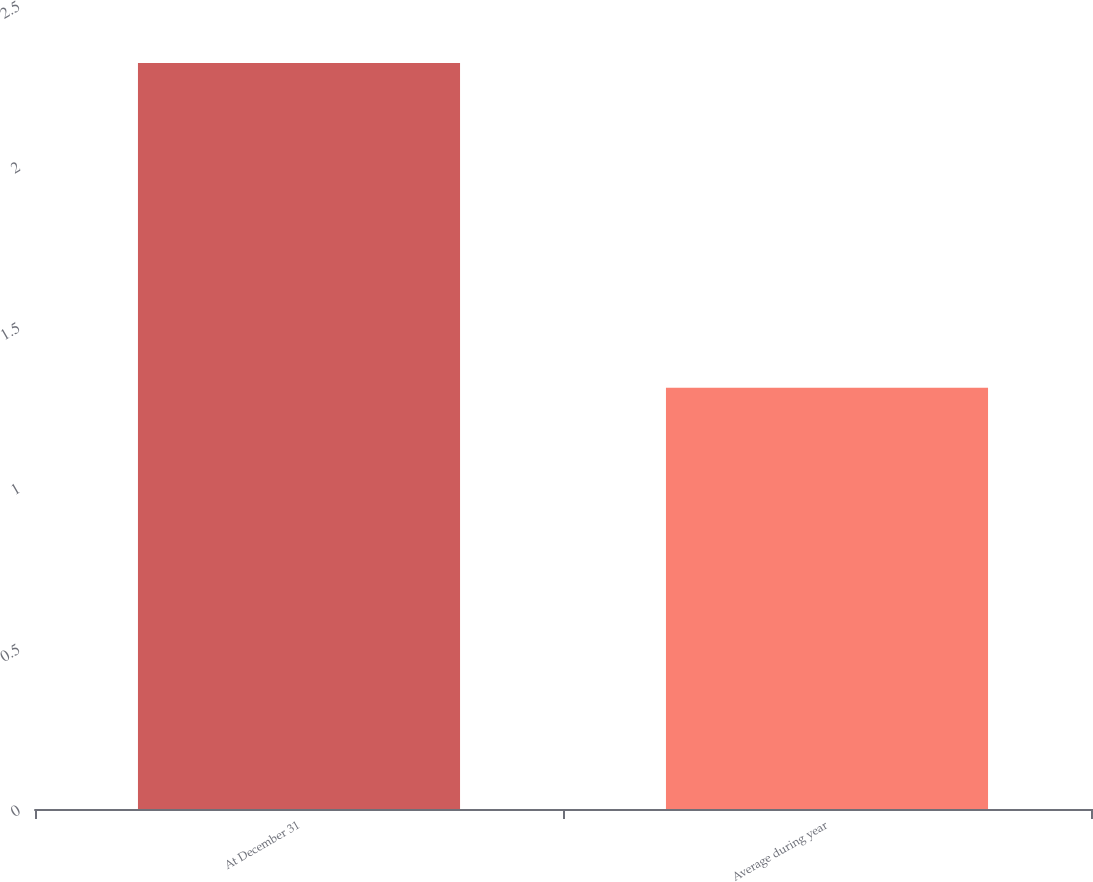<chart> <loc_0><loc_0><loc_500><loc_500><bar_chart><fcel>At December 31<fcel>Average during year<nl><fcel>2.32<fcel>1.31<nl></chart> 